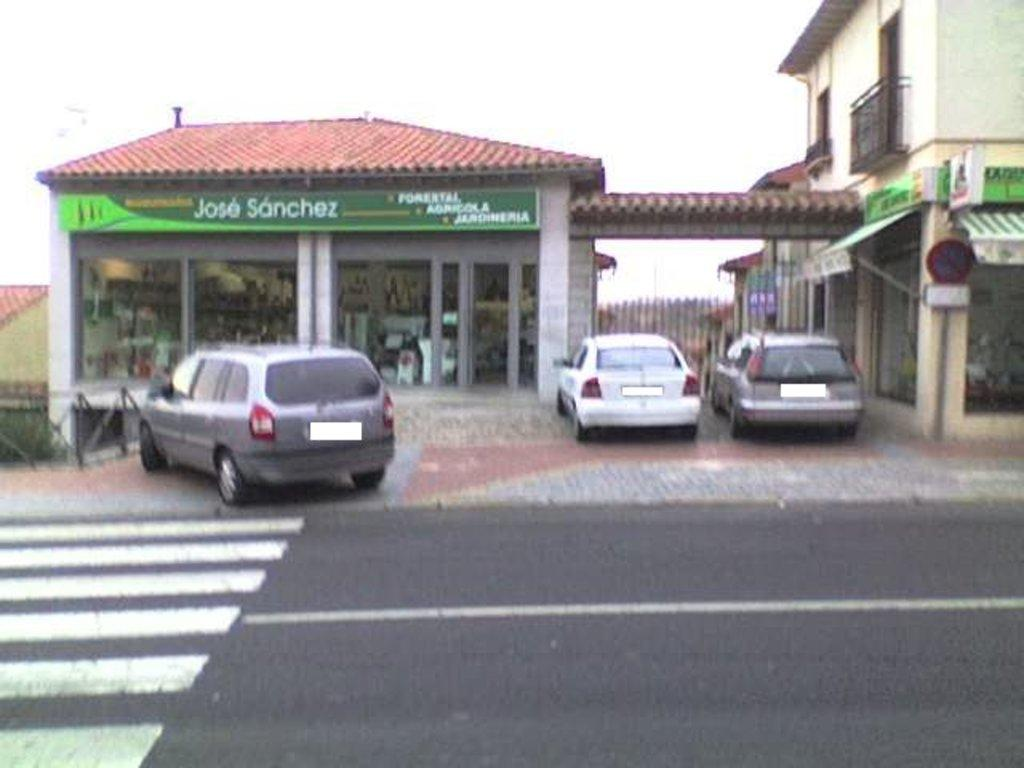What can be seen in the image? There are vehicles in the image. What is located in the background of the image? There is a stall in the background of the image, and it has a green color board attached to it. What type of building can be seen in the background? There is a building in cream color in the background of the image. What is the color of the sky in the image? The sky is visible in the image, and it appears to be white. Can you see a kite flying in the image? There is no kite visible in the image. 